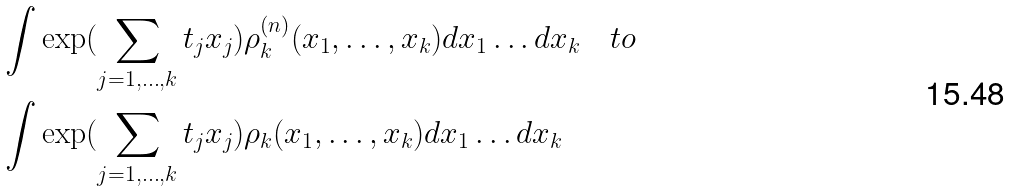Convert formula to latex. <formula><loc_0><loc_0><loc_500><loc_500>& \int \exp ( \sum _ { j = 1 , \dots , k } t _ { j } x _ { j } ) \rho _ { k } ^ { ( n ) } ( x _ { 1 } , \dots , x _ { k } ) d x _ { 1 } \dots d x _ { k } \quad t o \\ & \int \exp ( \sum _ { j = 1 , \dots , k } t _ { j } x _ { j } ) \rho _ { k } ( x _ { 1 } , \dots , x _ { k } ) d x _ { 1 } \dots d x _ { k }</formula> 